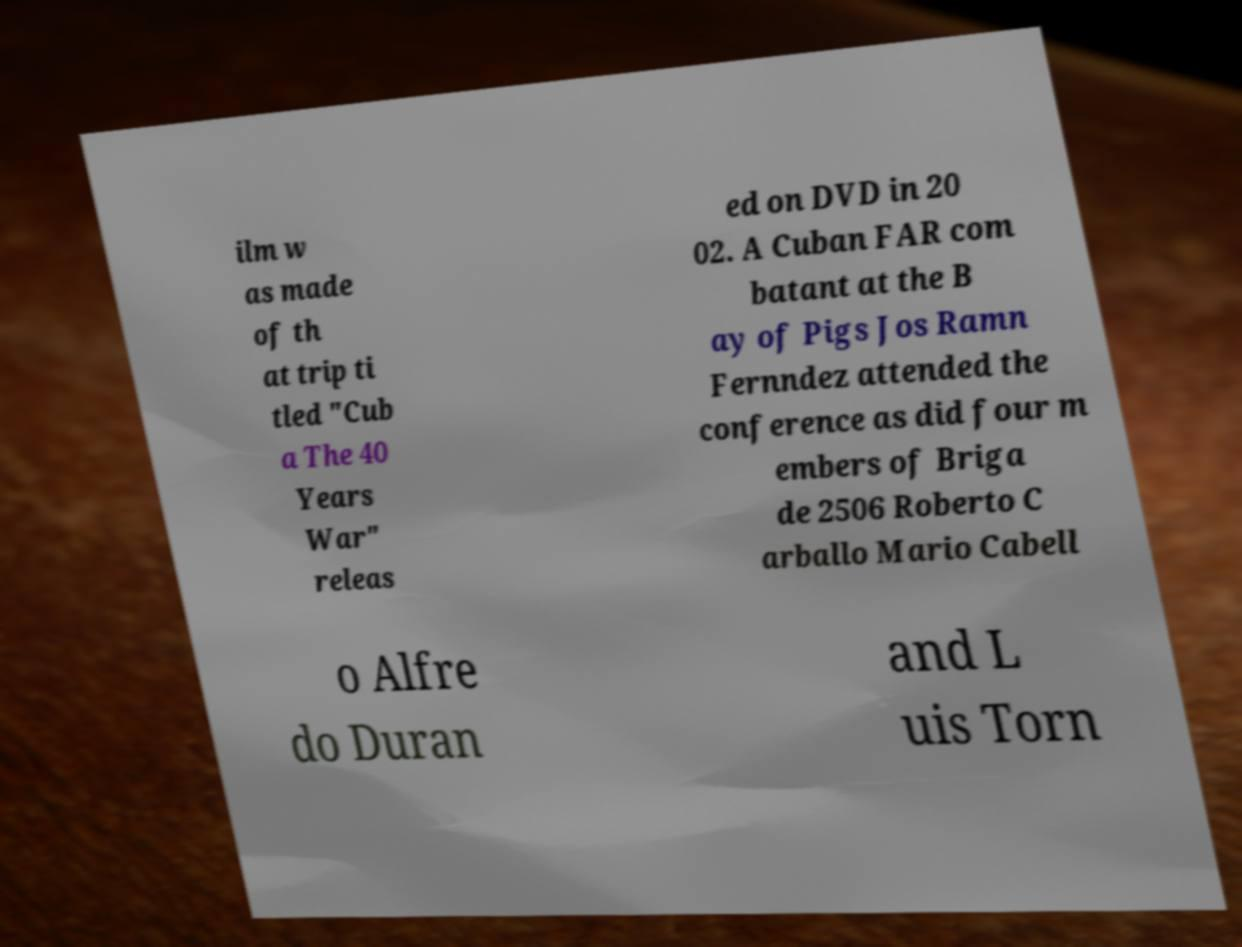Please identify and transcribe the text found in this image. ilm w as made of th at trip ti tled "Cub a The 40 Years War" releas ed on DVD in 20 02. A Cuban FAR com batant at the B ay of Pigs Jos Ramn Fernndez attended the conference as did four m embers of Briga de 2506 Roberto C arballo Mario Cabell o Alfre do Duran and L uis Torn 